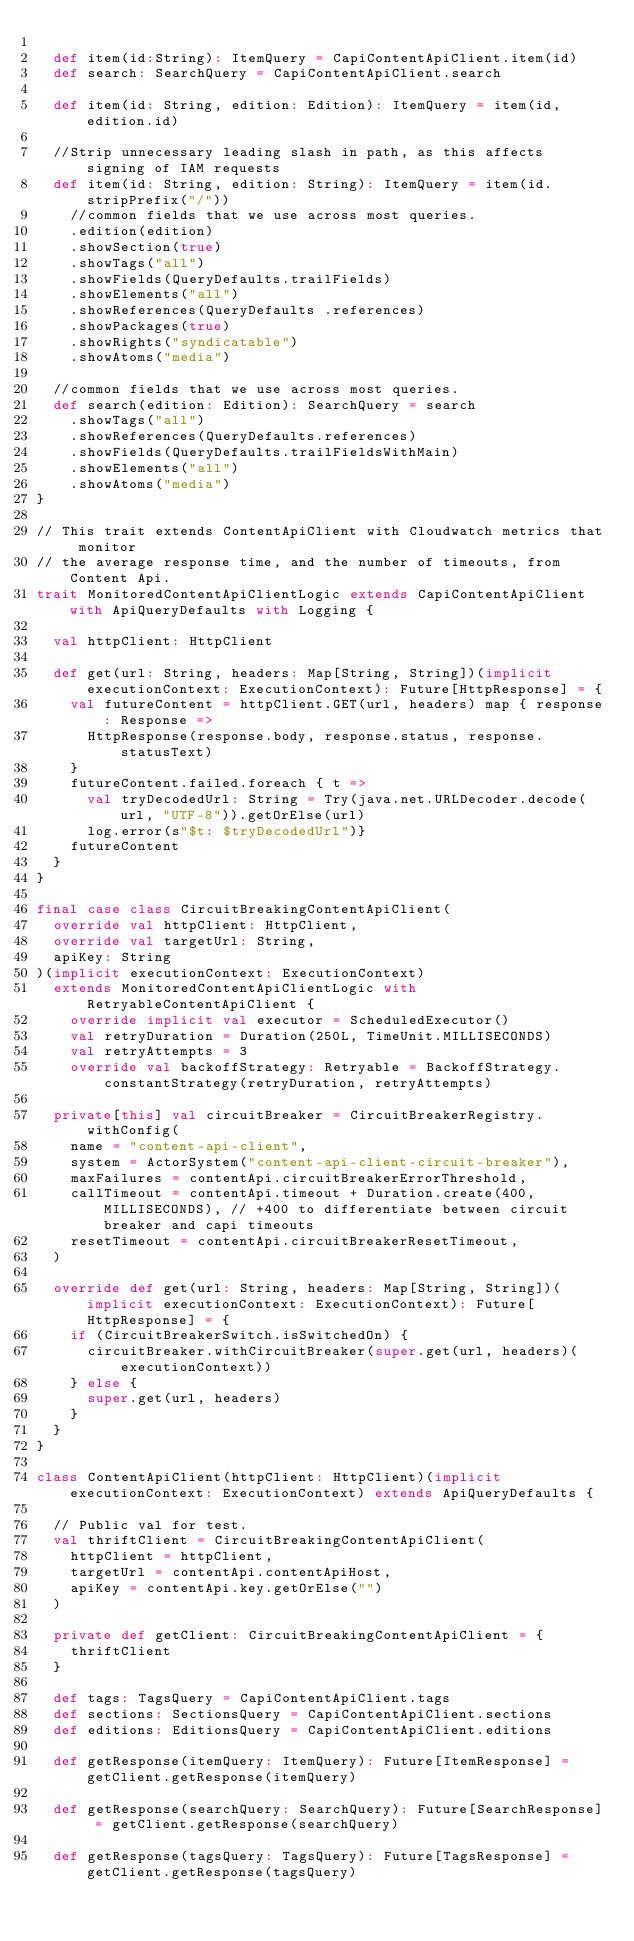<code> <loc_0><loc_0><loc_500><loc_500><_Scala_>
  def item(id:String): ItemQuery = CapiContentApiClient.item(id)
  def search: SearchQuery = CapiContentApiClient.search

  def item(id: String, edition: Edition): ItemQuery = item(id, edition.id)

  //Strip unnecessary leading slash in path, as this affects signing of IAM requests
  def item(id: String, edition: String): ItemQuery = item(id.stripPrefix("/"))
    //common fields that we use across most queries.
    .edition(edition)
    .showSection(true)
    .showTags("all")
    .showFields(QueryDefaults.trailFields)
    .showElements("all")
    .showReferences(QueryDefaults .references)
    .showPackages(true)
    .showRights("syndicatable")
    .showAtoms("media")

  //common fields that we use across most queries.
  def search(edition: Edition): SearchQuery = search
    .showTags("all")
    .showReferences(QueryDefaults.references)
    .showFields(QueryDefaults.trailFieldsWithMain)
    .showElements("all")
    .showAtoms("media")
}

// This trait extends ContentApiClient with Cloudwatch metrics that monitor
// the average response time, and the number of timeouts, from Content Api.
trait MonitoredContentApiClientLogic extends CapiContentApiClient with ApiQueryDefaults with Logging {

  val httpClient: HttpClient

  def get(url: String, headers: Map[String, String])(implicit executionContext: ExecutionContext): Future[HttpResponse] = {
    val futureContent = httpClient.GET(url, headers) map { response: Response =>
      HttpResponse(response.body, response.status, response.statusText)
    }
    futureContent.failed.foreach { t =>
      val tryDecodedUrl: String = Try(java.net.URLDecoder.decode(url, "UTF-8")).getOrElse(url)
      log.error(s"$t: $tryDecodedUrl")}
    futureContent
  }
}

final case class CircuitBreakingContentApiClient(
  override val httpClient: HttpClient,
  override val targetUrl: String,
  apiKey: String
)(implicit executionContext: ExecutionContext)
  extends MonitoredContentApiClientLogic with RetryableContentApiClient {
    override implicit val executor = ScheduledExecutor()
    val retryDuration = Duration(250L, TimeUnit.MILLISECONDS)
    val retryAttempts = 3
    override val backoffStrategy: Retryable = BackoffStrategy.constantStrategy(retryDuration, retryAttempts)

  private[this] val circuitBreaker = CircuitBreakerRegistry.withConfig(
    name = "content-api-client",
    system = ActorSystem("content-api-client-circuit-breaker"),
    maxFailures = contentApi.circuitBreakerErrorThreshold,
    callTimeout = contentApi.timeout + Duration.create(400, MILLISECONDS), // +400 to differentiate between circuit breaker and capi timeouts
    resetTimeout = contentApi.circuitBreakerResetTimeout,
  )

  override def get(url: String, headers: Map[String, String])(implicit executionContext: ExecutionContext): Future[HttpResponse] = {
    if (CircuitBreakerSwitch.isSwitchedOn) {
      circuitBreaker.withCircuitBreaker(super.get(url, headers)(executionContext))
    } else {
      super.get(url, headers)
    }
  }
}

class ContentApiClient(httpClient: HttpClient)(implicit executionContext: ExecutionContext) extends ApiQueryDefaults {

  // Public val for test.
  val thriftClient = CircuitBreakingContentApiClient(
    httpClient = httpClient,
    targetUrl = contentApi.contentApiHost,
    apiKey = contentApi.key.getOrElse("")
  )

  private def getClient: CircuitBreakingContentApiClient = {
    thriftClient
  }

  def tags: TagsQuery = CapiContentApiClient.tags
  def sections: SectionsQuery = CapiContentApiClient.sections
  def editions: EditionsQuery = CapiContentApiClient.editions

  def getResponse(itemQuery: ItemQuery): Future[ItemResponse] = getClient.getResponse(itemQuery)

  def getResponse(searchQuery: SearchQuery): Future[SearchResponse] = getClient.getResponse(searchQuery)

  def getResponse(tagsQuery: TagsQuery): Future[TagsResponse] = getClient.getResponse(tagsQuery)
</code> 